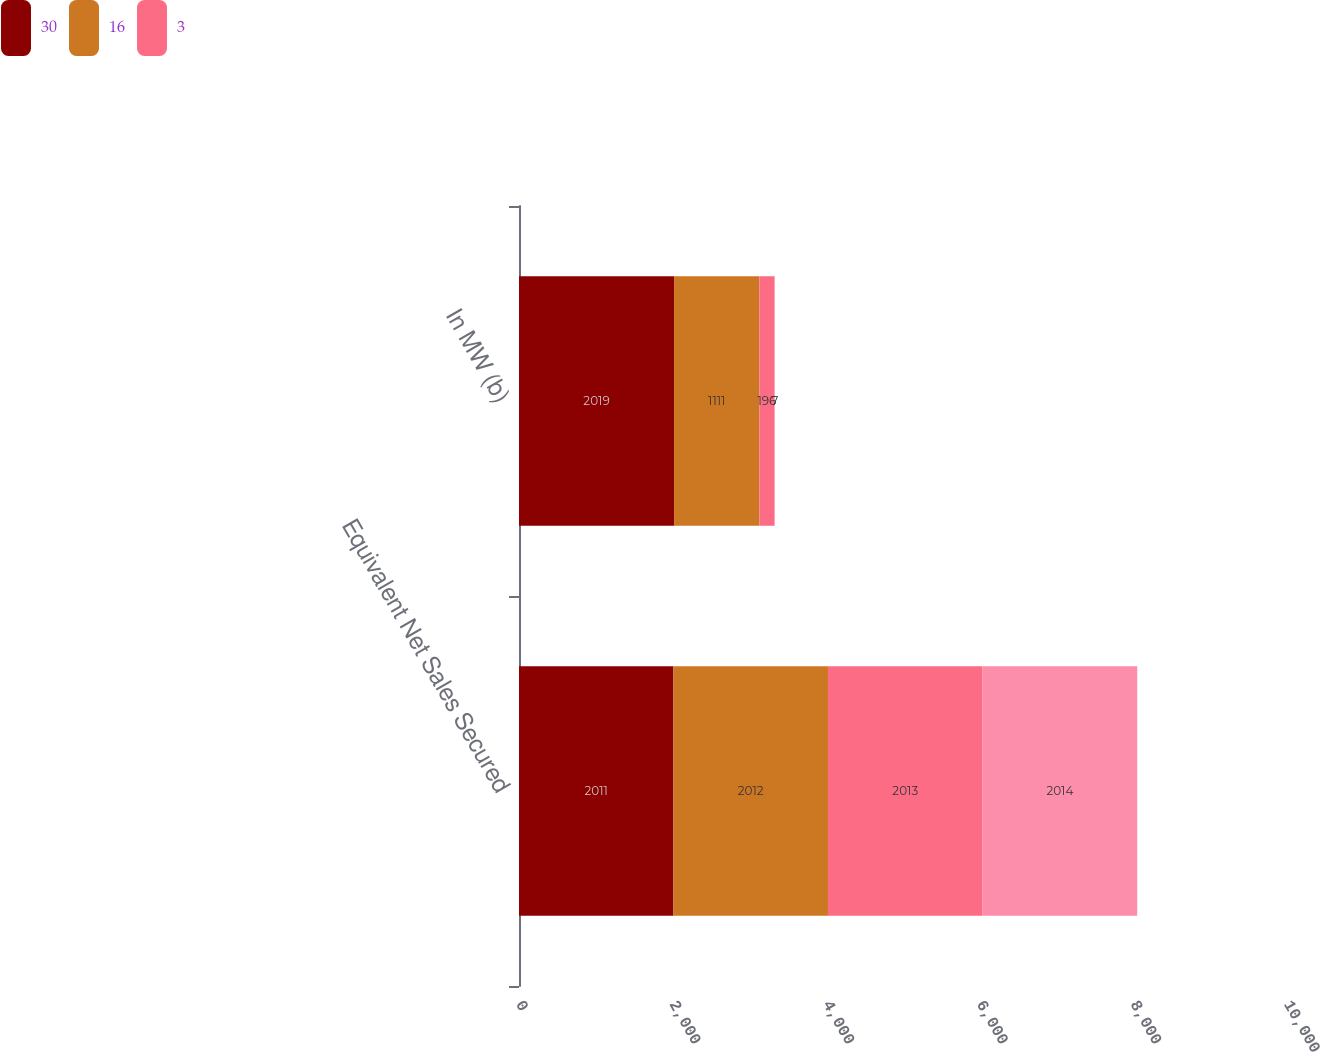Convert chart. <chart><loc_0><loc_0><loc_500><loc_500><stacked_bar_chart><ecel><fcel>Equivalent Net Sales Secured<fcel>In MW (b)<nl><fcel>30<fcel>2011<fcel>2019<nl><fcel>16<fcel>2012<fcel>1111<nl><fcel>3<fcel>2013<fcel>196<nl><fcel>nan<fcel>2014<fcel>7<nl></chart> 